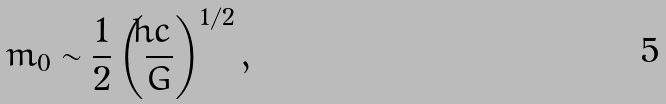<formula> <loc_0><loc_0><loc_500><loc_500>m _ { 0 } \sim \frac { 1 } { 2 } \left ( \frac { \hbar { c } } { G } \right ) ^ { 1 / 2 } ,</formula> 